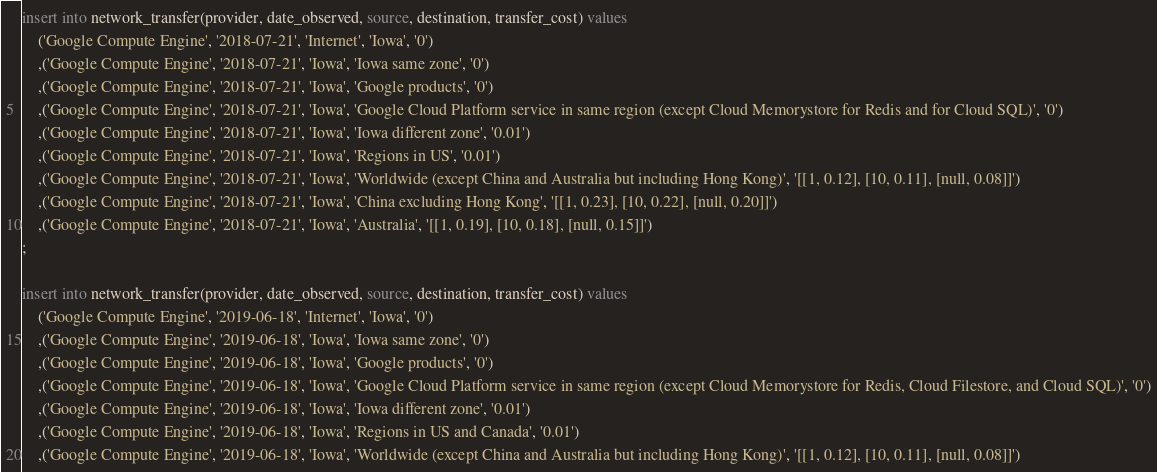<code> <loc_0><loc_0><loc_500><loc_500><_SQL_>insert into network_transfer(provider, date_observed, source, destination, transfer_cost) values
    ('Google Compute Engine', '2018-07-21', 'Internet', 'Iowa', '0')
    ,('Google Compute Engine', '2018-07-21', 'Iowa', 'Iowa same zone', '0')
    ,('Google Compute Engine', '2018-07-21', 'Iowa', 'Google products', '0')
    ,('Google Compute Engine', '2018-07-21', 'Iowa', 'Google Cloud Platform service in same region (except Cloud Memorystore for Redis and for Cloud SQL)', '0')
    ,('Google Compute Engine', '2018-07-21', 'Iowa', 'Iowa different zone', '0.01')
    ,('Google Compute Engine', '2018-07-21', 'Iowa', 'Regions in US', '0.01')
    ,('Google Compute Engine', '2018-07-21', 'Iowa', 'Worldwide (except China and Australia but including Hong Kong)', '[[1, 0.12], [10, 0.11], [null, 0.08]]')
    ,('Google Compute Engine', '2018-07-21', 'Iowa', 'China excluding Hong Kong', '[[1, 0.23], [10, 0.22], [null, 0.20]]')
    ,('Google Compute Engine', '2018-07-21', 'Iowa', 'Australia', '[[1, 0.19], [10, 0.18], [null, 0.15]]')
;

insert into network_transfer(provider, date_observed, source, destination, transfer_cost) values
    ('Google Compute Engine', '2019-06-18', 'Internet', 'Iowa', '0')
    ,('Google Compute Engine', '2019-06-18', 'Iowa', 'Iowa same zone', '0')
    ,('Google Compute Engine', '2019-06-18', 'Iowa', 'Google products', '0')
    ,('Google Compute Engine', '2019-06-18', 'Iowa', 'Google Cloud Platform service in same region (except Cloud Memorystore for Redis, Cloud Filestore, and Cloud SQL)', '0')
    ,('Google Compute Engine', '2019-06-18', 'Iowa', 'Iowa different zone', '0.01')
    ,('Google Compute Engine', '2019-06-18', 'Iowa', 'Regions in US and Canada', '0.01')
    ,('Google Compute Engine', '2019-06-18', 'Iowa', 'Worldwide (except China and Australia but including Hong Kong)', '[[1, 0.12], [10, 0.11], [null, 0.08]]')</code> 